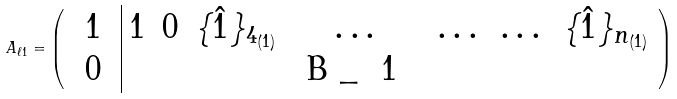<formula> <loc_0><loc_0><loc_500><loc_500>A _ { \ell 1 } = { \left ( \begin{array} { c | c c c c c c c } 1 & 1 & 0 & \{ \hat { 1 } \} _ { 4 _ { ( 1 ) } } & \dots & \dots & \dots & \{ \hat { 1 } \} _ { n _ { ( 1 ) } } \\ $ 0 $ & & & & $ B _ { 1 } $ & & & \end{array} \right ) }</formula> 